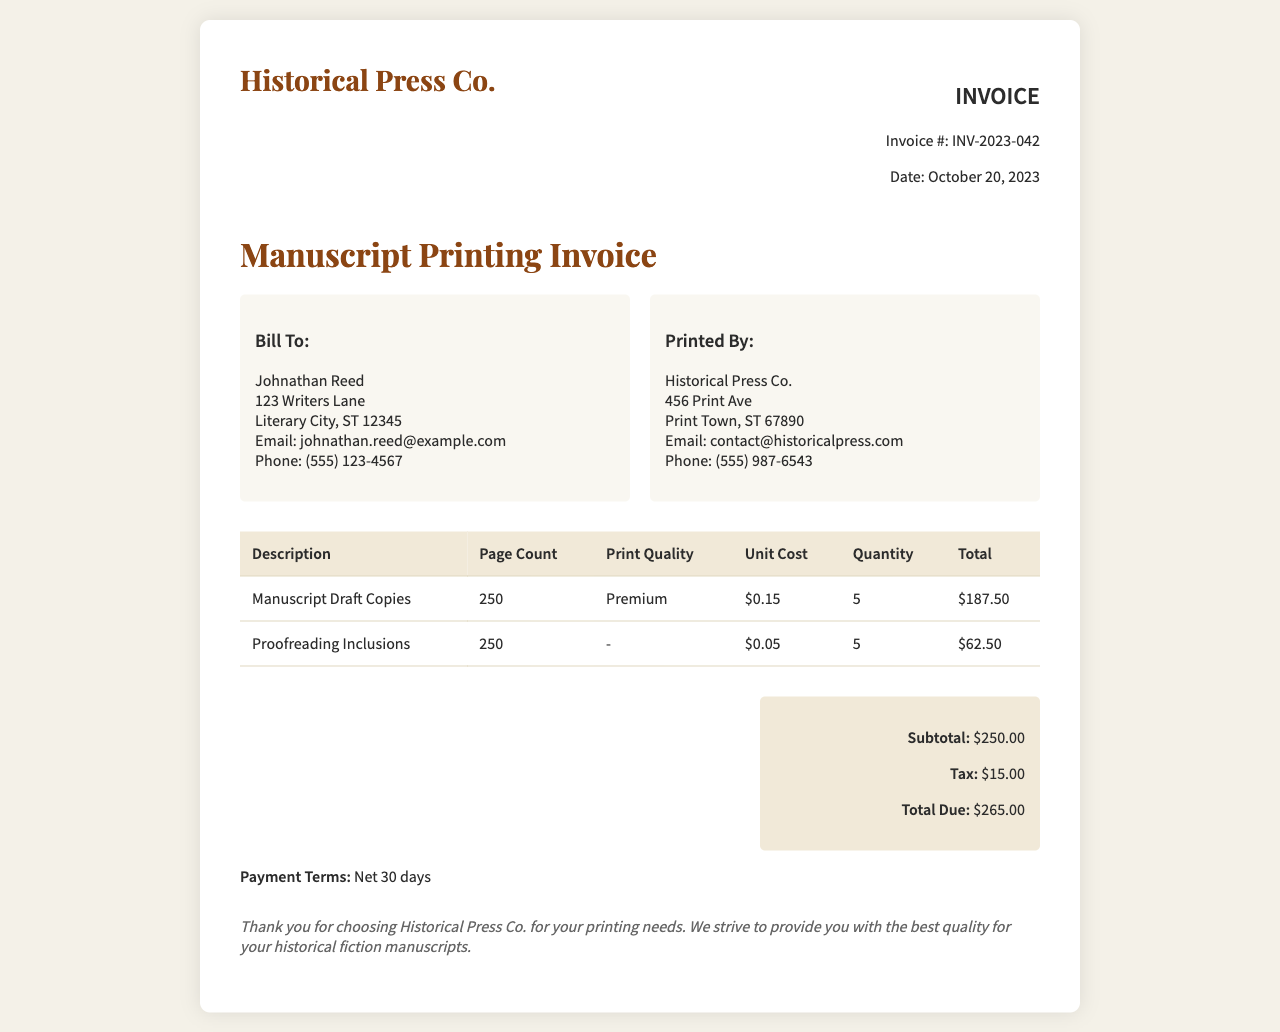What is the invoice number? The invoice number is found in the invoice details, labeled as "Invoice #".
Answer: INV-2023-042 What is the date of the invoice? The date is provided in the invoice details, labeled as "Date".
Answer: October 20, 2023 Who is the invoice billed to? The billing information is listed under "Bill To:", which provides the name of the individual.
Answer: Johnathan Reed What is the total due amount? The total due is specified in the totals section, labeled as "Total Due".
Answer: $265.00 How many manuscript draft copies were printed? The page count for manuscript draft copies is listed in the invoice table under "Page Count".
Answer: 250 What is the unit cost of proofreading inclusions? The unit cost is provided in the table under "Unit Cost".
Answer: $0.05 Is tax included in the total? The total due calculation includes a line for tax, indicating its presence.
Answer: Yes What is the print quality selected for the manuscript draft copies? The invoice specifies the print quality in the table under the "Print Quality" column.
Answer: Premium What payment terms are listed in the invoice? The payment terms are explicitly mentioned at the bottom of the invoice.
Answer: Net 30 days 